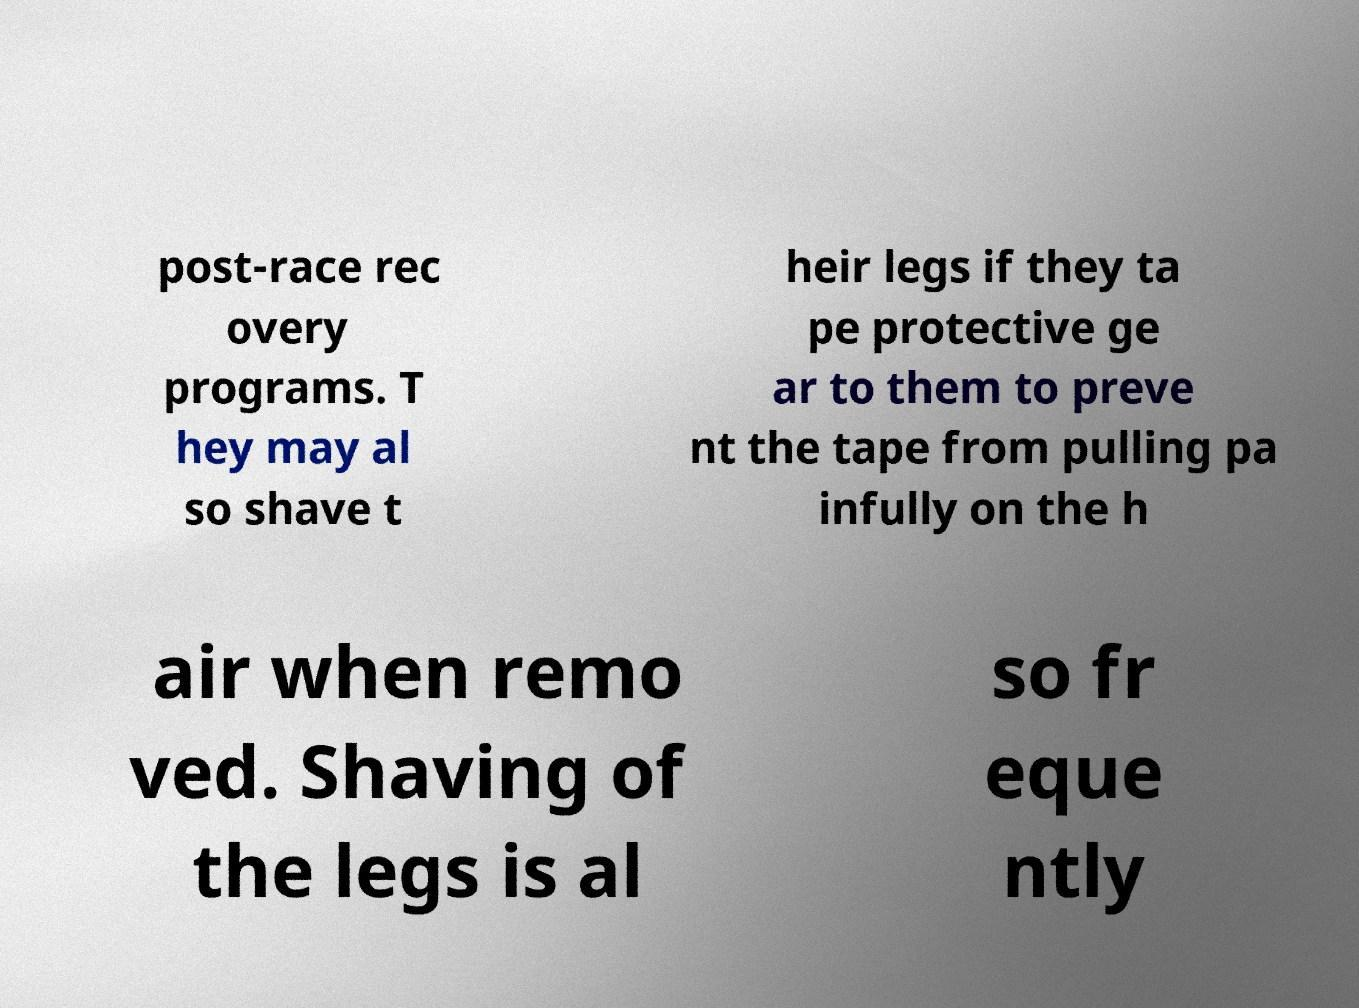Can you accurately transcribe the text from the provided image for me? post-race rec overy programs. T hey may al so shave t heir legs if they ta pe protective ge ar to them to preve nt the tape from pulling pa infully on the h air when remo ved. Shaving of the legs is al so fr eque ntly 